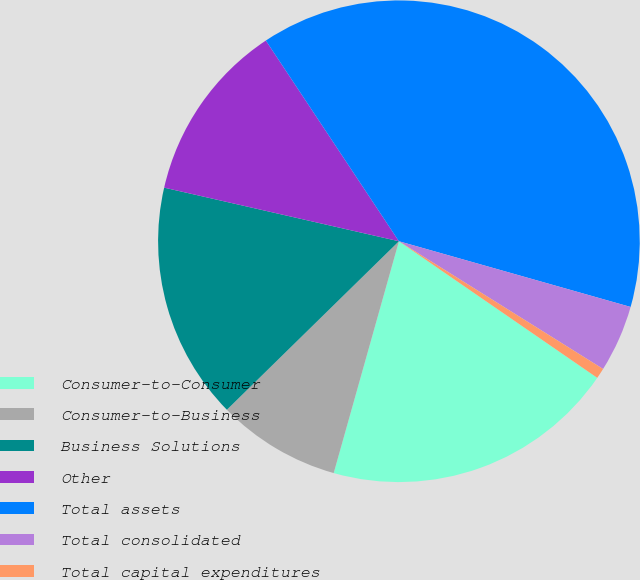Convert chart. <chart><loc_0><loc_0><loc_500><loc_500><pie_chart><fcel>Consumer-to-Consumer<fcel>Consumer-to-Business<fcel>Business Solutions<fcel>Other<fcel>Total assets<fcel>Total consolidated<fcel>Total capital expenditures<nl><fcel>19.77%<fcel>8.3%<fcel>15.91%<fcel>12.11%<fcel>38.72%<fcel>4.5%<fcel>0.7%<nl></chart> 